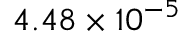Convert formula to latex. <formula><loc_0><loc_0><loc_500><loc_500>4 . 4 8 \times 1 0 ^ { - 5 }</formula> 